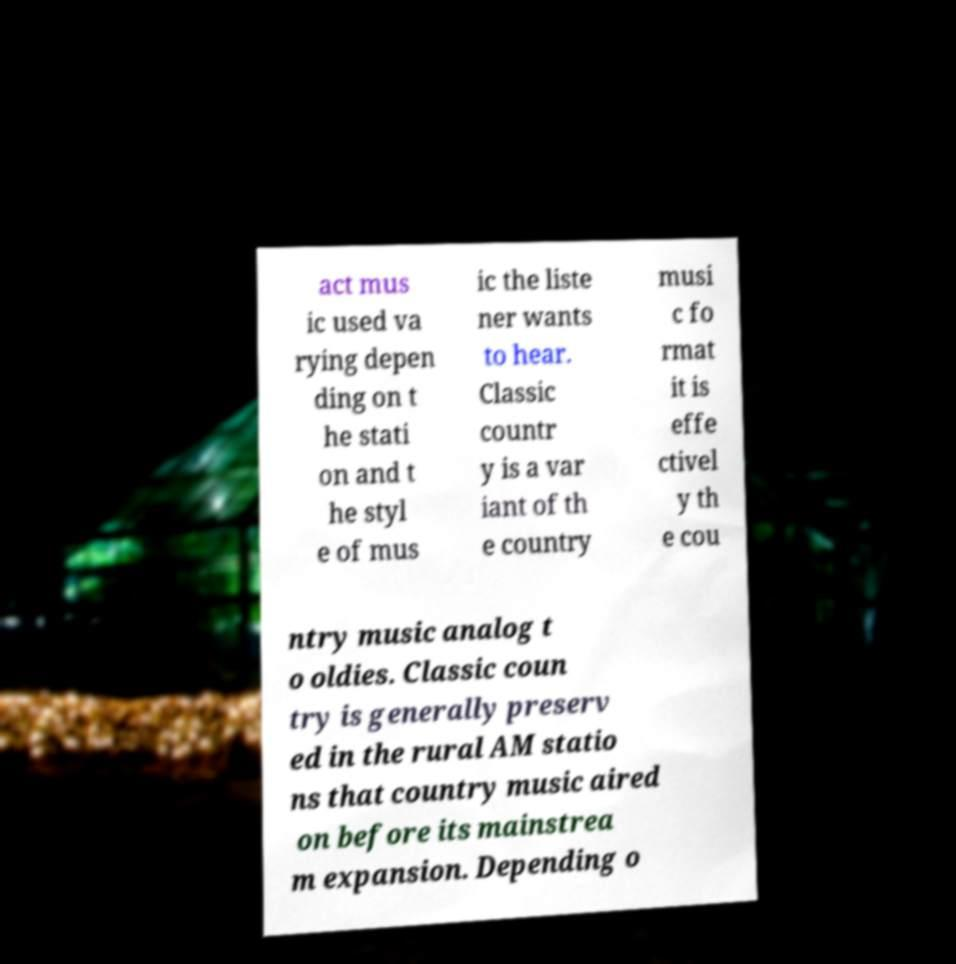Please read and relay the text visible in this image. What does it say? act mus ic used va rying depen ding on t he stati on and t he styl e of mus ic the liste ner wants to hear. Classic countr y is a var iant of th e country musi c fo rmat it is effe ctivel y th e cou ntry music analog t o oldies. Classic coun try is generally preserv ed in the rural AM statio ns that country music aired on before its mainstrea m expansion. Depending o 